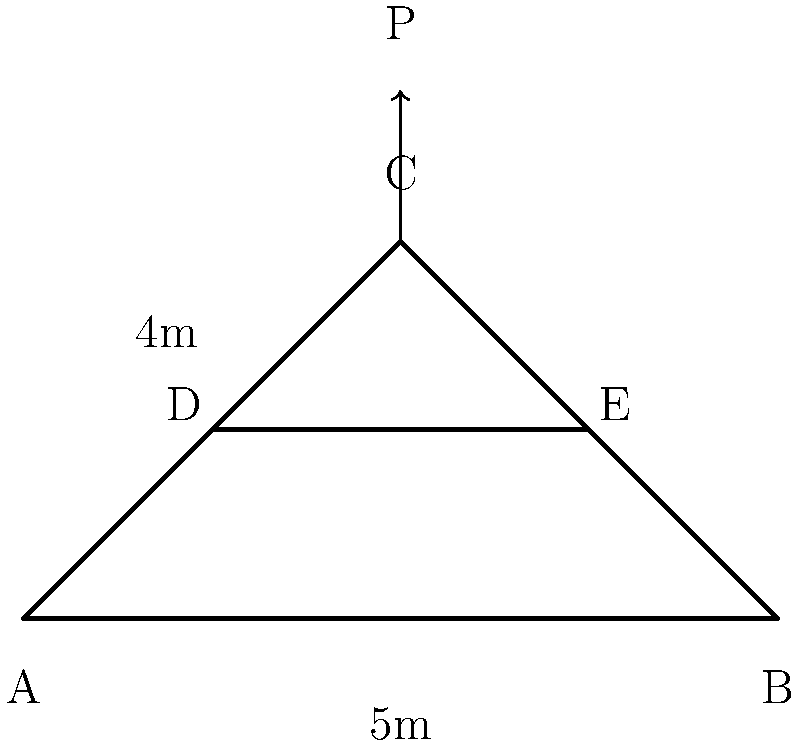As a marketing manager with experience in running an Etsy shop, you're tasked with designing a simple truss bridge for a product photoshoot. The bridge has a span of 5 meters and a height of 4 meters, as shown in the diagram. If the maximum allowable stress in any member is 200 MPa and each member has a cross-sectional area of 500 mm², what is the maximum load P (in kN) that can be applied at point C without exceeding the allowable stress? To solve this problem, we'll follow these steps:

1) First, we need to determine the forces in each member using the method of joints or method of sections. For simplicity, let's focus on joint C.

2) At joint C, we have three forces: the applied load P and the forces in members CD and CE. Due to symmetry, the forces in CD and CE will be equal. Let's call this force F.

3) For equilibrium in the vertical direction:
   $$P = 2F \sin \theta$$
   where $\theta$ is the angle between the horizontal and member CD or CE.

4) We can find $\sin \theta$ using the bridge dimensions:
   $$\sin \theta = \frac{4}{5} = 0.8$$

5) Substituting this into our equilibrium equation:
   $$P = 2F (0.8) = 1.6F$$

6) Now, we know that the maximum allowable stress is 200 MPa. The stress in a member is given by force divided by area:
   $$\sigma = \frac{F}{A} \leq 200 \text{ MPa}$$

7) Solving for F:
   $$F \leq 200 \text{ MPa} \times 500 \text{ mm}^2 = 100,000 \text{ N} = 100 \text{ kN}$$

8) Now we can find the maximum load P:
   $$P = 1.6F = 1.6 \times 100 \text{ kN} = 160 \text{ kN}$$

Therefore, the maximum load that can be applied at point C is 160 kN.
Answer: 160 kN 